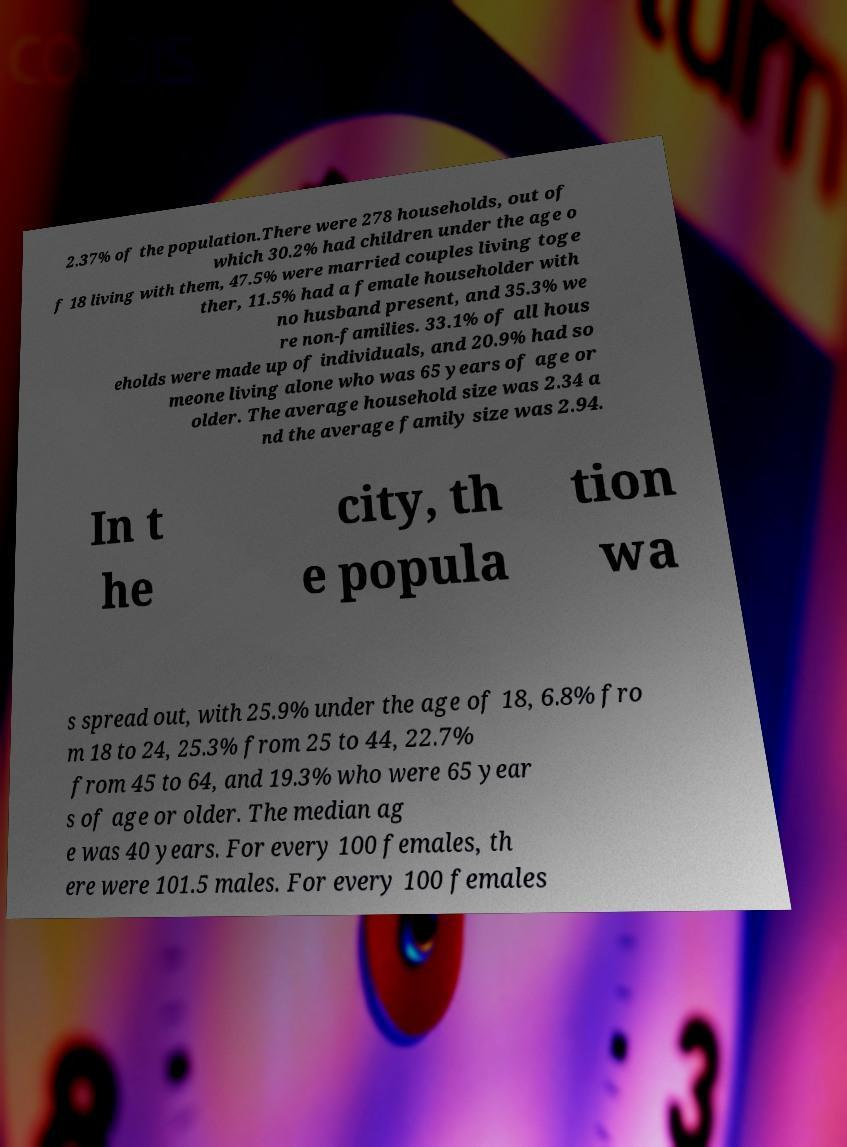There's text embedded in this image that I need extracted. Can you transcribe it verbatim? 2.37% of the population.There were 278 households, out of which 30.2% had children under the age o f 18 living with them, 47.5% were married couples living toge ther, 11.5% had a female householder with no husband present, and 35.3% we re non-families. 33.1% of all hous eholds were made up of individuals, and 20.9% had so meone living alone who was 65 years of age or older. The average household size was 2.34 a nd the average family size was 2.94. In t he city, th e popula tion wa s spread out, with 25.9% under the age of 18, 6.8% fro m 18 to 24, 25.3% from 25 to 44, 22.7% from 45 to 64, and 19.3% who were 65 year s of age or older. The median ag e was 40 years. For every 100 females, th ere were 101.5 males. For every 100 females 